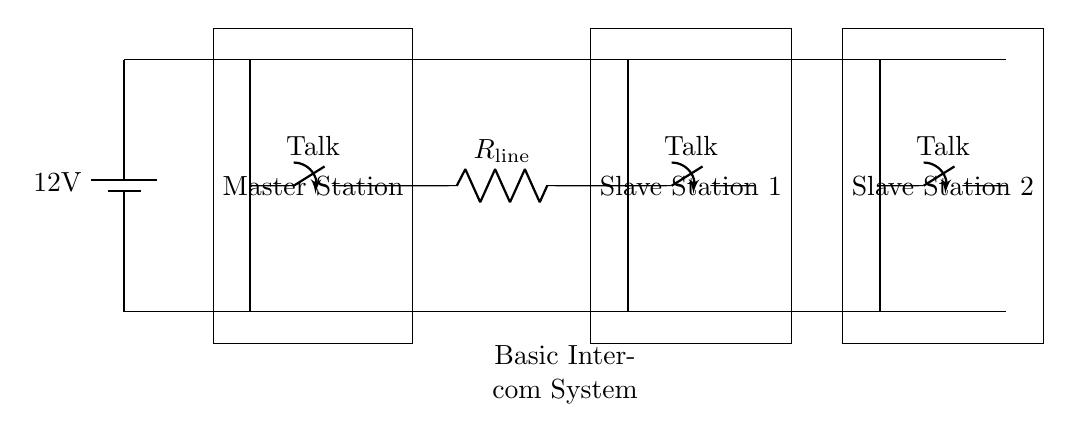What is the voltage supplied to the intercom system? The voltage supplied to the intercom system is indicated by the battery symbol at the left side of the diagram. The label shows it is 12 volts.
Answer: 12 volts How many stations are there in total? The diagram shows one master station and two slave stations. Summing these gives a total of three stations in the intercom system.
Answer: Three What component represents the master station? In the diagram, the master station is represented by a rectangular box with the label "Master Station," located to the left of the slave stations.
Answer: Master Station What type of switch is used at each station for communication? The switches used at each station are labeled as "spst," which stands for a single-pole single-throw switch, indicating they control the connection for talk at each station.
Answer: Single-pole single-throw switch How does the transmission line connect the master station to the slave stations? The transmission line connects the master station to slave stations through a resistor labeled "R_line." The diagram shows a direct line going from the master to the first slave, and then considering the connections, it continues to the second slave.
Answer: Through a resistor What is the purpose of the resistor labeled R_line? The resistor R_line in the circuit serves to limit the current flow between the master and slave stations, thereby managing signal levels and preventing damage to the system from excessive current.
Answer: To limit current flow 